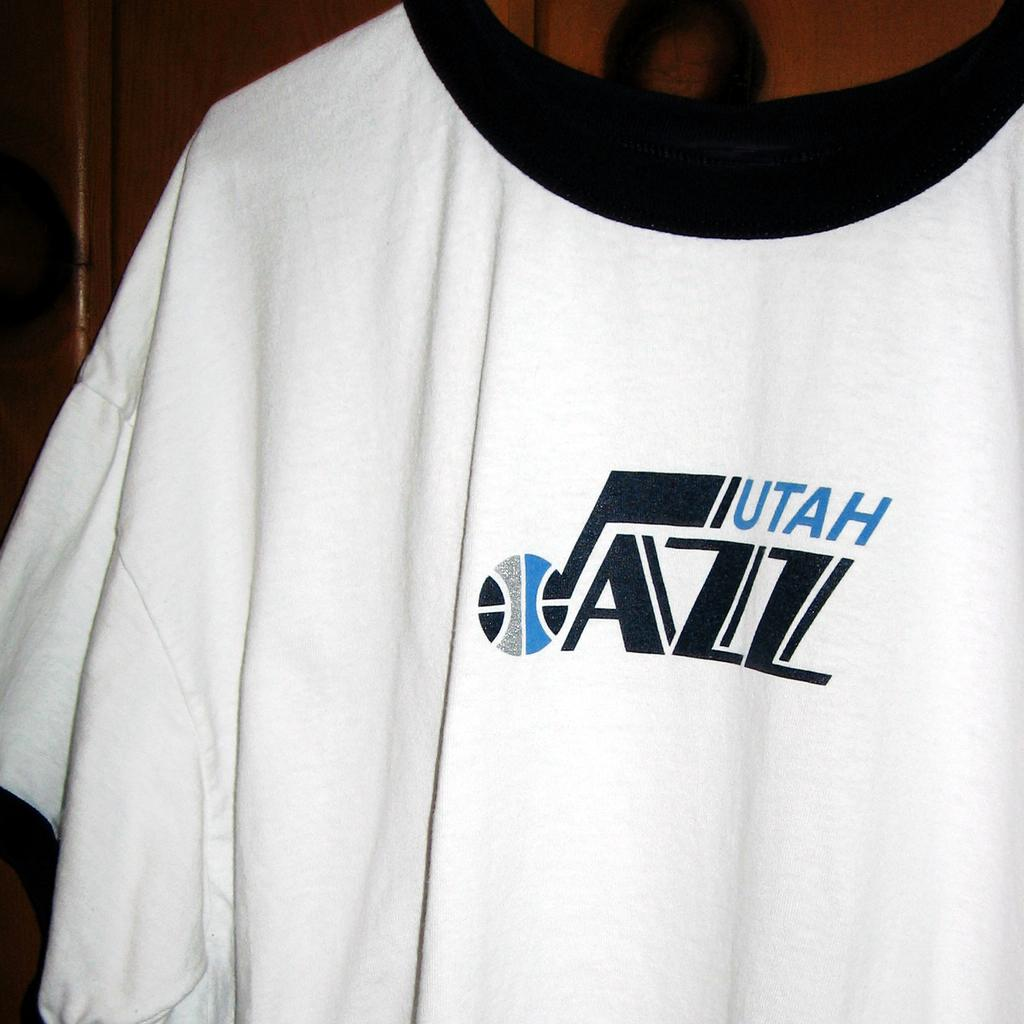Provide a one-sentence caption for the provided image. A tee shirt extra large in white with Jazz Utah logo. 